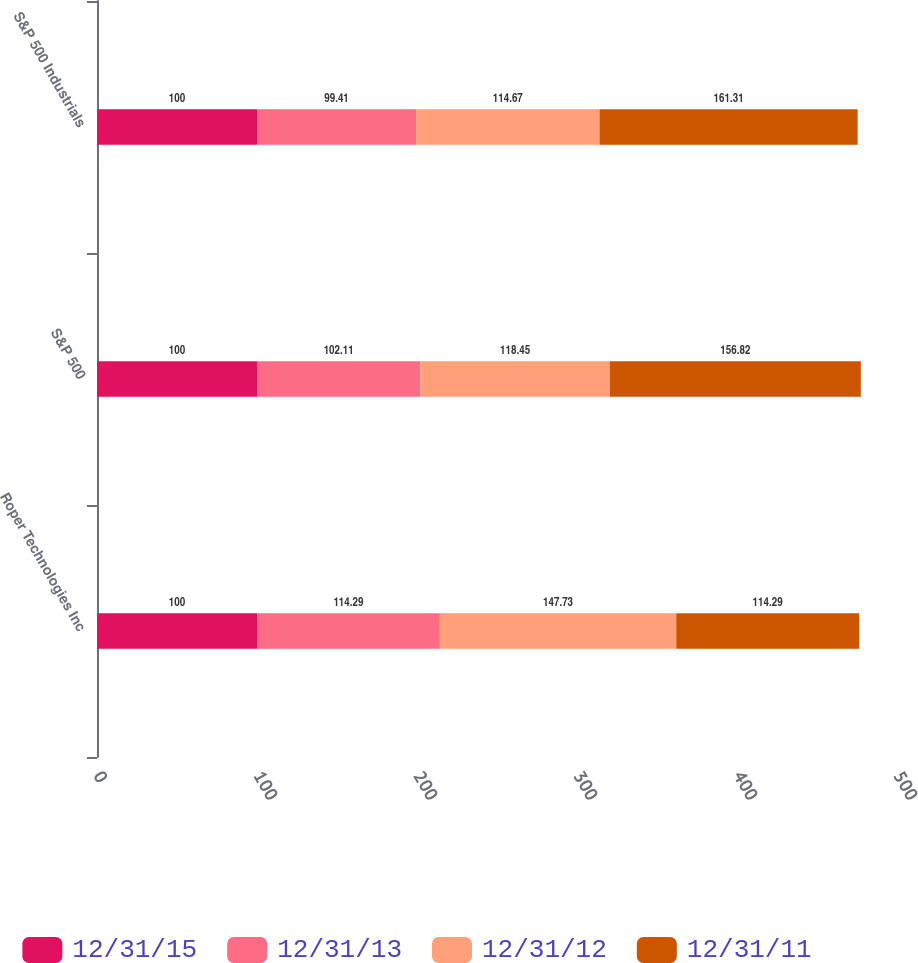Convert chart. <chart><loc_0><loc_0><loc_500><loc_500><stacked_bar_chart><ecel><fcel>Roper Technologies Inc<fcel>S&P 500<fcel>S&P 500 Industrials<nl><fcel>12/31/15<fcel>100<fcel>100<fcel>100<nl><fcel>12/31/13<fcel>114.29<fcel>102.11<fcel>99.41<nl><fcel>12/31/12<fcel>147.73<fcel>118.45<fcel>114.67<nl><fcel>12/31/11<fcel>114.29<fcel>156.82<fcel>161.31<nl></chart> 